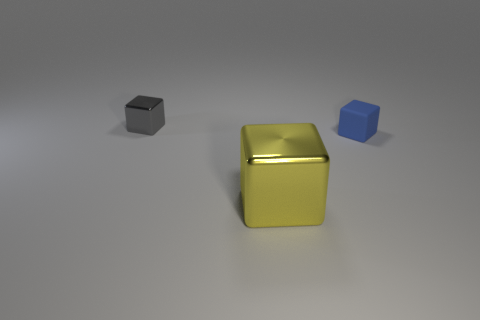Subtract all big yellow shiny blocks. How many blocks are left? 2 Subtract 1 blocks. How many blocks are left? 2 Add 2 tiny things. How many objects exist? 5 Subtract all cyan blocks. Subtract all gray cylinders. How many blocks are left? 3 Add 1 yellow objects. How many yellow objects are left? 2 Add 3 big shiny objects. How many big shiny objects exist? 4 Subtract 0 green cubes. How many objects are left? 3 Subtract all big metal objects. Subtract all tiny yellow spheres. How many objects are left? 2 